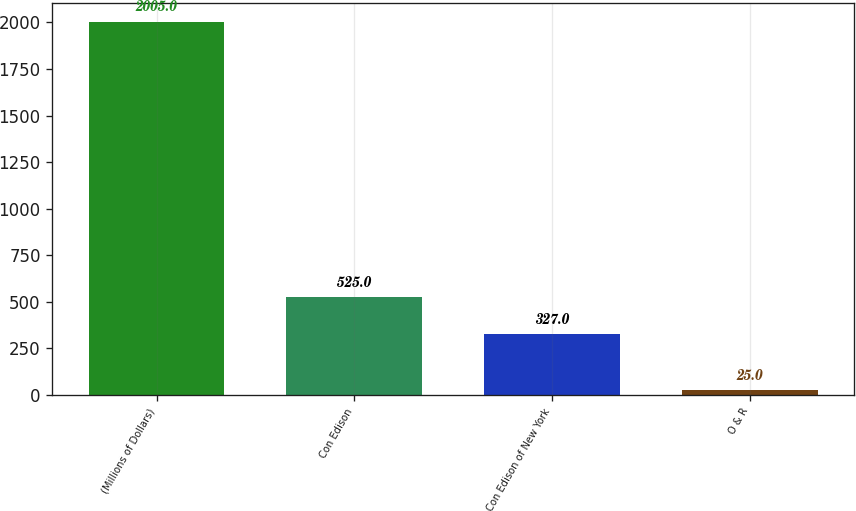Convert chart to OTSL. <chart><loc_0><loc_0><loc_500><loc_500><bar_chart><fcel>(Millions of Dollars)<fcel>Con Edison<fcel>Con Edison of New York<fcel>O & R<nl><fcel>2005<fcel>525<fcel>327<fcel>25<nl></chart> 